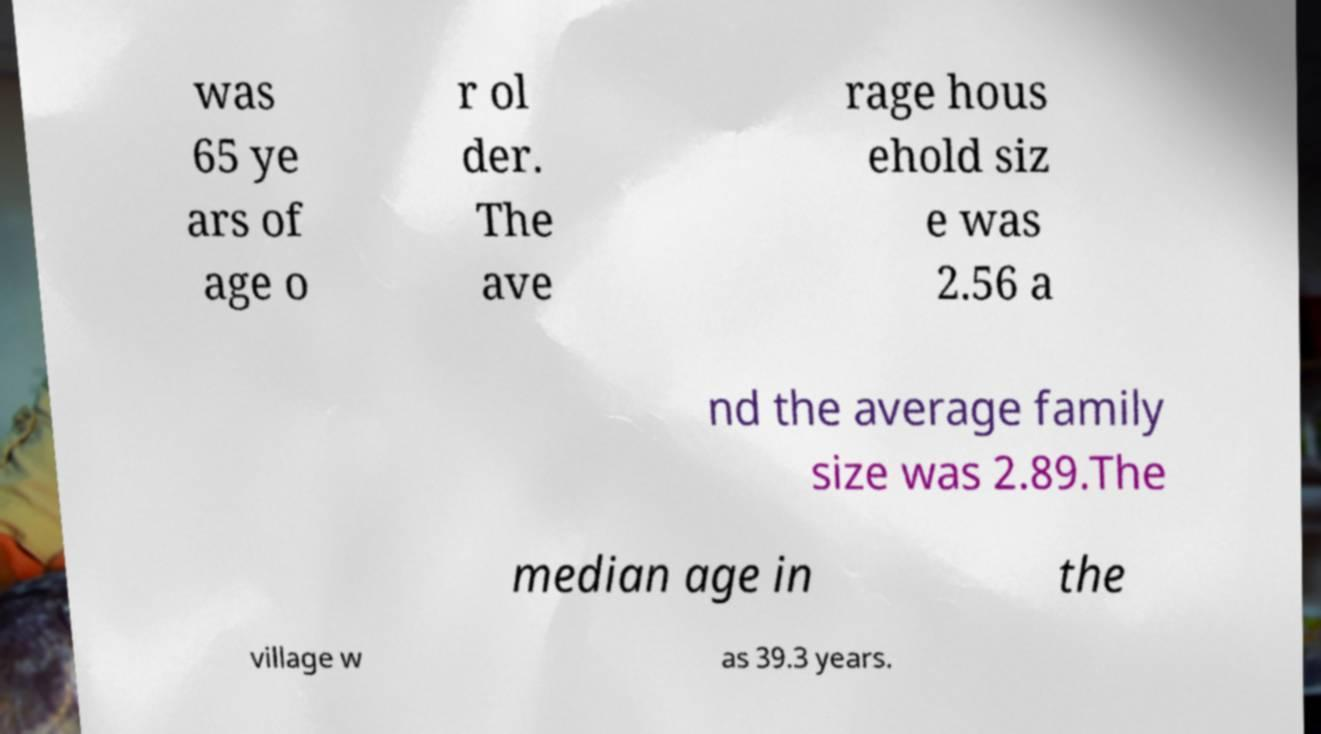For documentation purposes, I need the text within this image transcribed. Could you provide that? was 65 ye ars of age o r ol der. The ave rage hous ehold siz e was 2.56 a nd the average family size was 2.89.The median age in the village w as 39.3 years. 